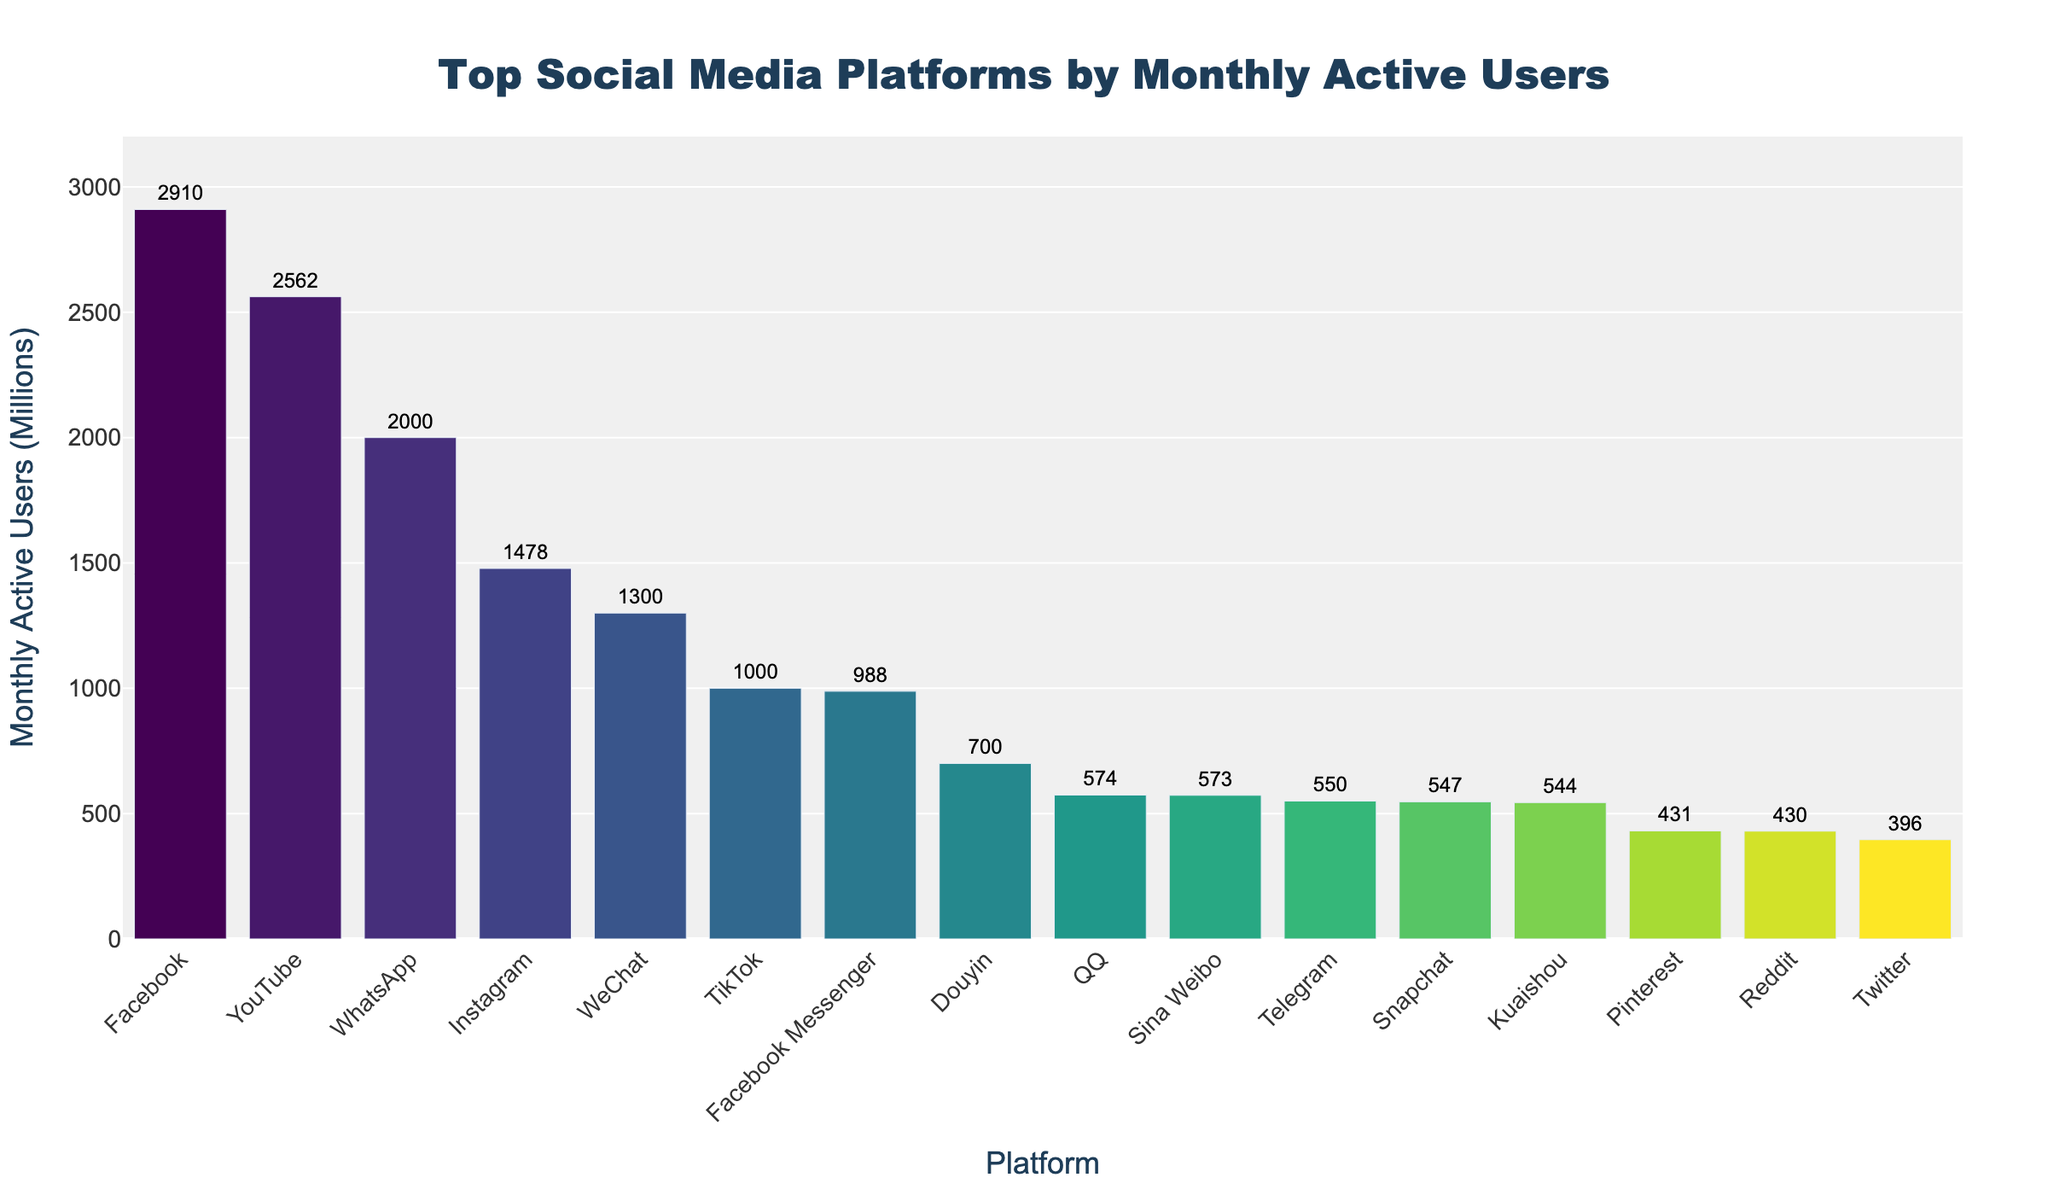What's the total number of monthly active users for the top three platforms? The top three platforms by monthly active users are Facebook, YouTube, and WhatsApp, with 2910 million, 2562 million, and 2000 million users respectively. Summing these amounts 2910 + 2562 + 2000 gives a total of 7472 million.
Answer: 7472 million Which platform has fewer monthly active users: TikTok or Instagram? TikTok has 1000 million monthly active users, while Instagram has 1478 million. Since 1000 is less than 1478, TikTok has fewer users than Instagram.
Answer: TikTok What's the total number of monthly active users for all platforms shown in the figure? Adding up the monthly active users for all platforms shown in the figure: 2910 + 2562 + 2000 + 1478 + 1300 + 1000 + 988 + 700 + 574 + 573 + 550 + 547 + 544 + 431 + 396 + 430 = 17983 million.
Answer: 17983 million What’s the difference in monthly active users between Facebook Messenger and WeChat? Facebook Messenger has 988 million users, and WeChat has 1300 million users. The difference is 1300 - 988 = 312 million.
Answer: 312 million Which color bar represents Telegram? In the bar chart, Telegram's position is determined as the 11th highest by monthly active users. This position corresponds to the 11th color in the Viridis colorscale used, which is typically a shade of greenish-yellow.
Answer: greenish-yellow How many platforms have more than 1000 million monthly active users? The platforms with more than 1000 million monthly active users are Facebook, YouTube, WhatsApp, Instagram, and WeChat. Thus, there are 5 such platforms.
Answer: 5 What's the average number of monthly active users for the platforms from positions 5 to 7 (WeChat, TikTok, and Facebook Messenger)? WeChat has 1300 million, TikTok has 1000 million, and Facebook Messenger has 988 million. The sum is 1300 + 1000 + 988 = 3288 million. The average is 3288 / 3 ≈ 1096 million.
Answer: 1096 million Which platform has the smallest number of monthly active users? Among the platforms listed, Twitter has the smallest number of monthly active users with 396 million.
Answer: Twitter 